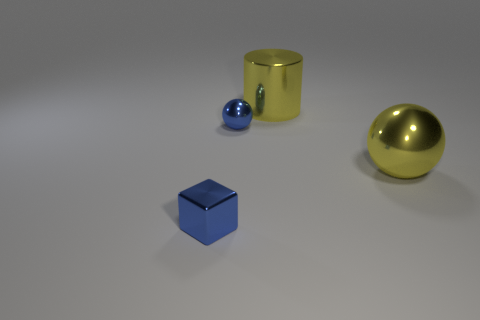Add 2 small shiny objects. How many objects exist? 6 Subtract all blocks. How many objects are left? 3 Subtract 0 brown cylinders. How many objects are left? 4 Subtract all yellow metal objects. Subtract all large green rubber cylinders. How many objects are left? 2 Add 1 large yellow balls. How many large yellow balls are left? 2 Add 3 yellow metal balls. How many yellow metal balls exist? 4 